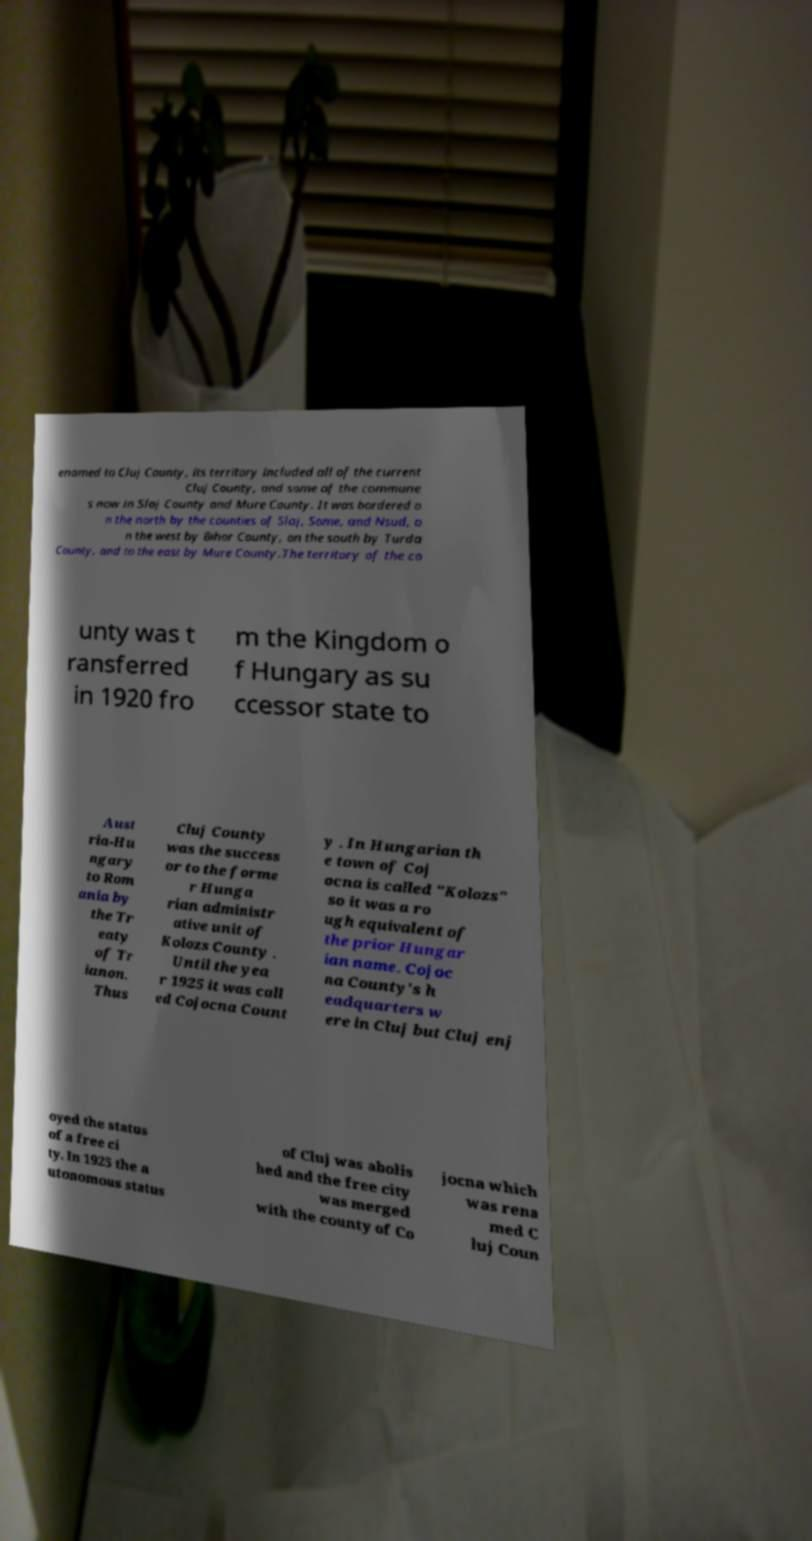Could you assist in decoding the text presented in this image and type it out clearly? enamed to Cluj County, its territory included all of the current Cluj County, and some of the commune s now in Slaj County and Mure County. It was bordered o n the north by the counties of Slaj, Some, and Nsud, o n the west by Bihor County, on the south by Turda County, and to the east by Mure County.The territory of the co unty was t ransferred in 1920 fro m the Kingdom o f Hungary as su ccessor state to Aust ria-Hu ngary to Rom ania by the Tr eaty of Tr ianon. Thus Cluj County was the success or to the forme r Hunga rian administr ative unit of Kolozs County . Until the yea r 1925 it was call ed Cojocna Count y . In Hungarian th e town of Coj ocna is called "Kolozs" so it was a ro ugh equivalent of the prior Hungar ian name. Cojoc na County's h eadquarters w ere in Cluj but Cluj enj oyed the status of a free ci ty. In 1925 the a utonomous status of Cluj was abolis hed and the free city was merged with the county of Co jocna which was rena med C luj Coun 